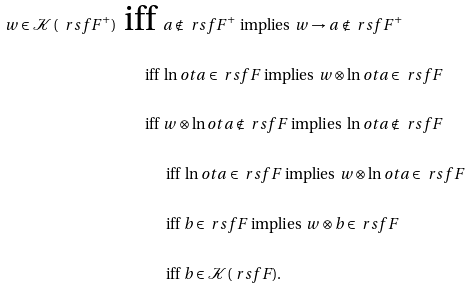<formula> <loc_0><loc_0><loc_500><loc_500>w \in \mathcal { K } ( \ r s f F ^ { + } ) \text { iff } & a \notin \ r s f F ^ { + } \text { implies } w \to a \notin \ r s f F ^ { + } \\ \text { iff } & \ln o t a \in \ r s f F \text { implies } w \otimes \ln o t a \in \ r s f F \\ \text { iff } & w \otimes \ln o t a \notin \ r s f F \text { implies } \ln o t a \notin \ r s f F \\ & \text { iff } \ln o t a \in \ r s f F \text { implies } w \otimes \ln o t a \in \ r s f F \\ & \text { iff } b \in \ r s f F \text { implies } w \otimes b \in \ r s f F \\ & \text { iff } b \in \mathcal { K } ( \ r s f F ) .</formula> 